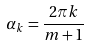Convert formula to latex. <formula><loc_0><loc_0><loc_500><loc_500>\alpha _ { k } = \frac { 2 \pi k } { m + 1 }</formula> 